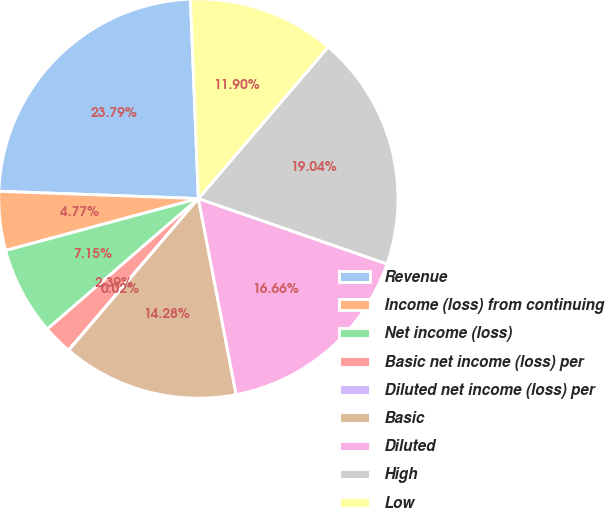Convert chart to OTSL. <chart><loc_0><loc_0><loc_500><loc_500><pie_chart><fcel>Revenue<fcel>Income (loss) from continuing<fcel>Net income (loss)<fcel>Basic net income (loss) per<fcel>Diluted net income (loss) per<fcel>Basic<fcel>Diluted<fcel>High<fcel>Low<nl><fcel>23.79%<fcel>4.77%<fcel>7.15%<fcel>2.39%<fcel>0.02%<fcel>14.28%<fcel>16.66%<fcel>19.04%<fcel>11.9%<nl></chart> 